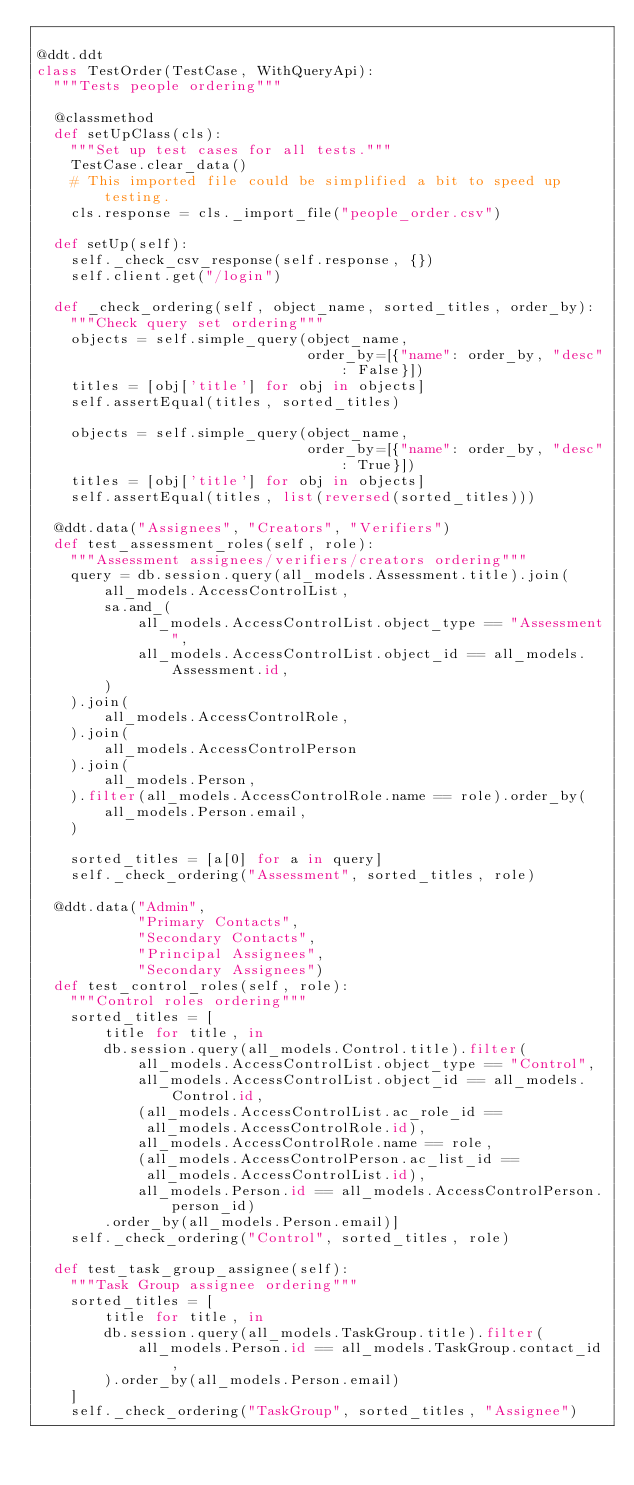<code> <loc_0><loc_0><loc_500><loc_500><_Python_>
@ddt.ddt
class TestOrder(TestCase, WithQueryApi):
  """Tests people ordering"""

  @classmethod
  def setUpClass(cls):
    """Set up test cases for all tests."""
    TestCase.clear_data()
    # This imported file could be simplified a bit to speed up testing.
    cls.response = cls._import_file("people_order.csv")

  def setUp(self):
    self._check_csv_response(self.response, {})
    self.client.get("/login")

  def _check_ordering(self, object_name, sorted_titles, order_by):
    """Check query set ordering"""
    objects = self.simple_query(object_name,
                                order_by=[{"name": order_by, "desc": False}])
    titles = [obj['title'] for obj in objects]
    self.assertEqual(titles, sorted_titles)

    objects = self.simple_query(object_name,
                                order_by=[{"name": order_by, "desc": True}])
    titles = [obj['title'] for obj in objects]
    self.assertEqual(titles, list(reversed(sorted_titles)))

  @ddt.data("Assignees", "Creators", "Verifiers")
  def test_assessment_roles(self, role):
    """Assessment assignees/verifiers/creators ordering"""
    query = db.session.query(all_models.Assessment.title).join(
        all_models.AccessControlList,
        sa.and_(
            all_models.AccessControlList.object_type == "Assessment",
            all_models.AccessControlList.object_id == all_models.Assessment.id,
        )
    ).join(
        all_models.AccessControlRole,
    ).join(
        all_models.AccessControlPerson
    ).join(
        all_models.Person,
    ).filter(all_models.AccessControlRole.name == role).order_by(
        all_models.Person.email,
    )

    sorted_titles = [a[0] for a in query]
    self._check_ordering("Assessment", sorted_titles, role)

  @ddt.data("Admin",
            "Primary Contacts",
            "Secondary Contacts",
            "Principal Assignees",
            "Secondary Assignees")
  def test_control_roles(self, role):
    """Control roles ordering"""
    sorted_titles = [
        title for title, in
        db.session.query(all_models.Control.title).filter(
            all_models.AccessControlList.object_type == "Control",
            all_models.AccessControlList.object_id == all_models.Control.id,
            (all_models.AccessControlList.ac_role_id ==
             all_models.AccessControlRole.id),
            all_models.AccessControlRole.name == role,
            (all_models.AccessControlPerson.ac_list_id ==
             all_models.AccessControlList.id),
            all_models.Person.id == all_models.AccessControlPerson.person_id)
        .order_by(all_models.Person.email)]
    self._check_ordering("Control", sorted_titles, role)

  def test_task_group_assignee(self):
    """Task Group assignee ordering"""
    sorted_titles = [
        title for title, in
        db.session.query(all_models.TaskGroup.title).filter(
            all_models.Person.id == all_models.TaskGroup.contact_id,
        ).order_by(all_models.Person.email)
    ]
    self._check_ordering("TaskGroup", sorted_titles, "Assignee")
</code> 